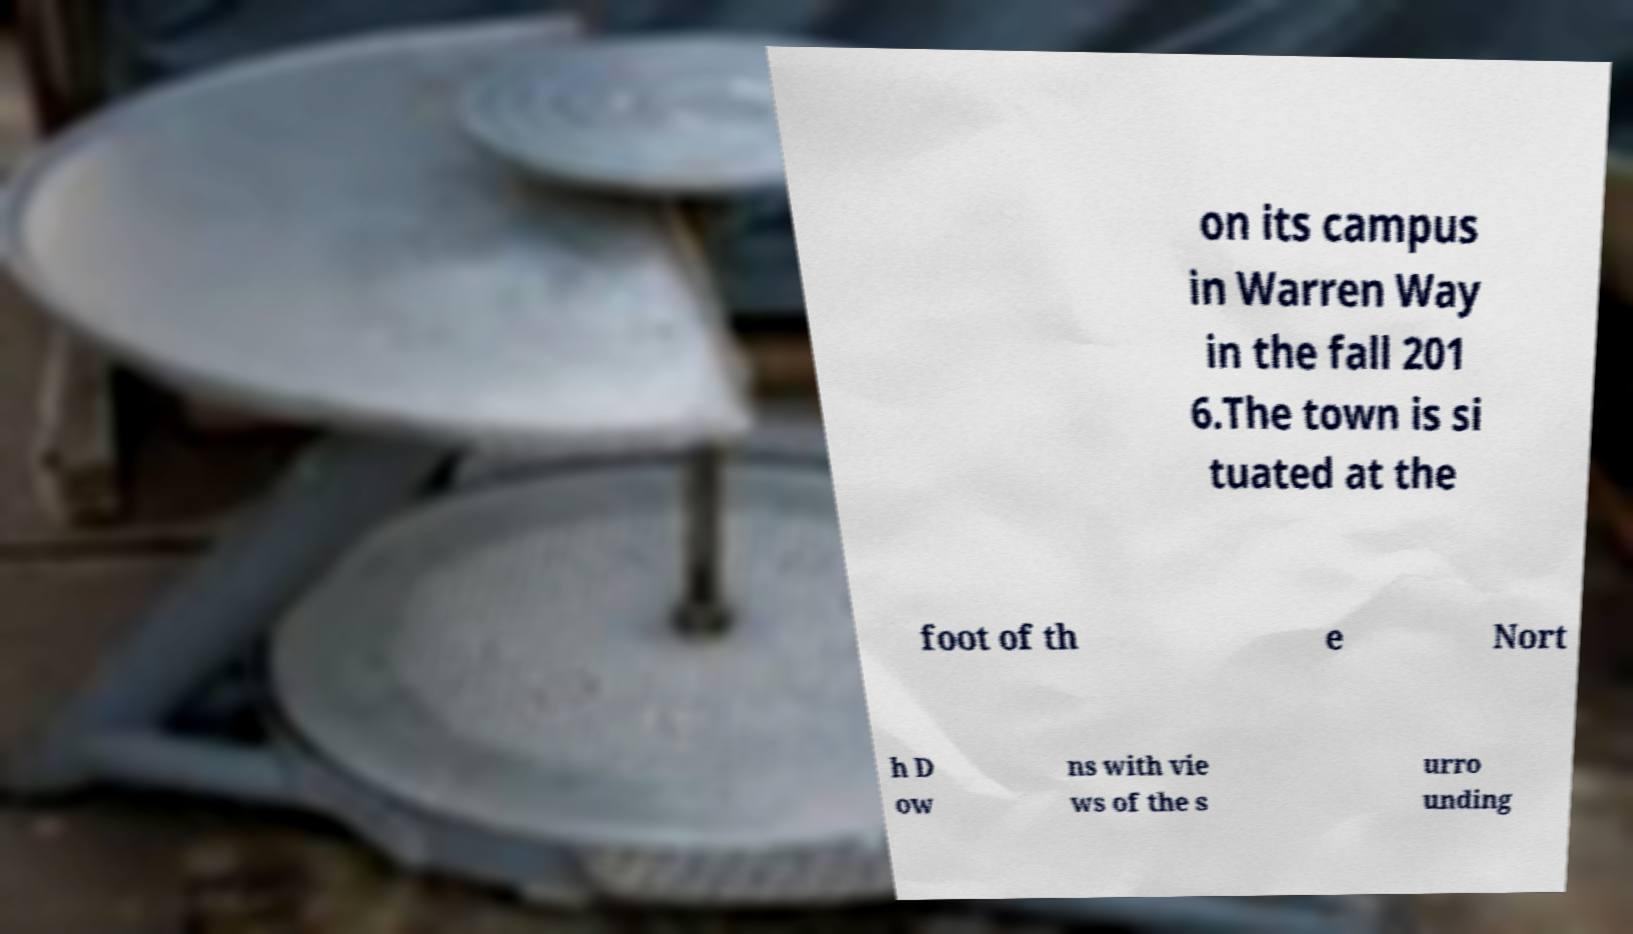Can you read and provide the text displayed in the image?This photo seems to have some interesting text. Can you extract and type it out for me? on its campus in Warren Way in the fall 201 6.The town is si tuated at the foot of th e Nort h D ow ns with vie ws of the s urro unding 